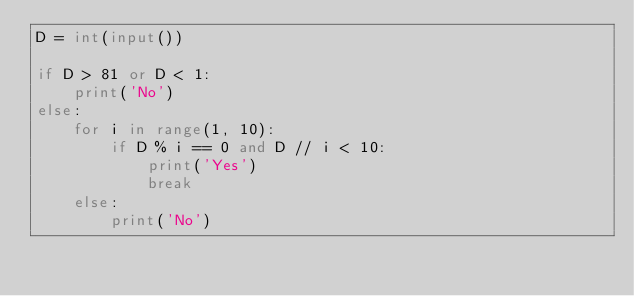Convert code to text. <code><loc_0><loc_0><loc_500><loc_500><_Python_>D = int(input())

if D > 81 or D < 1:
    print('No')
else:
    for i in range(1, 10):
        if D % i == 0 and D // i < 10:
            print('Yes')
            break
    else:
        print('No')</code> 